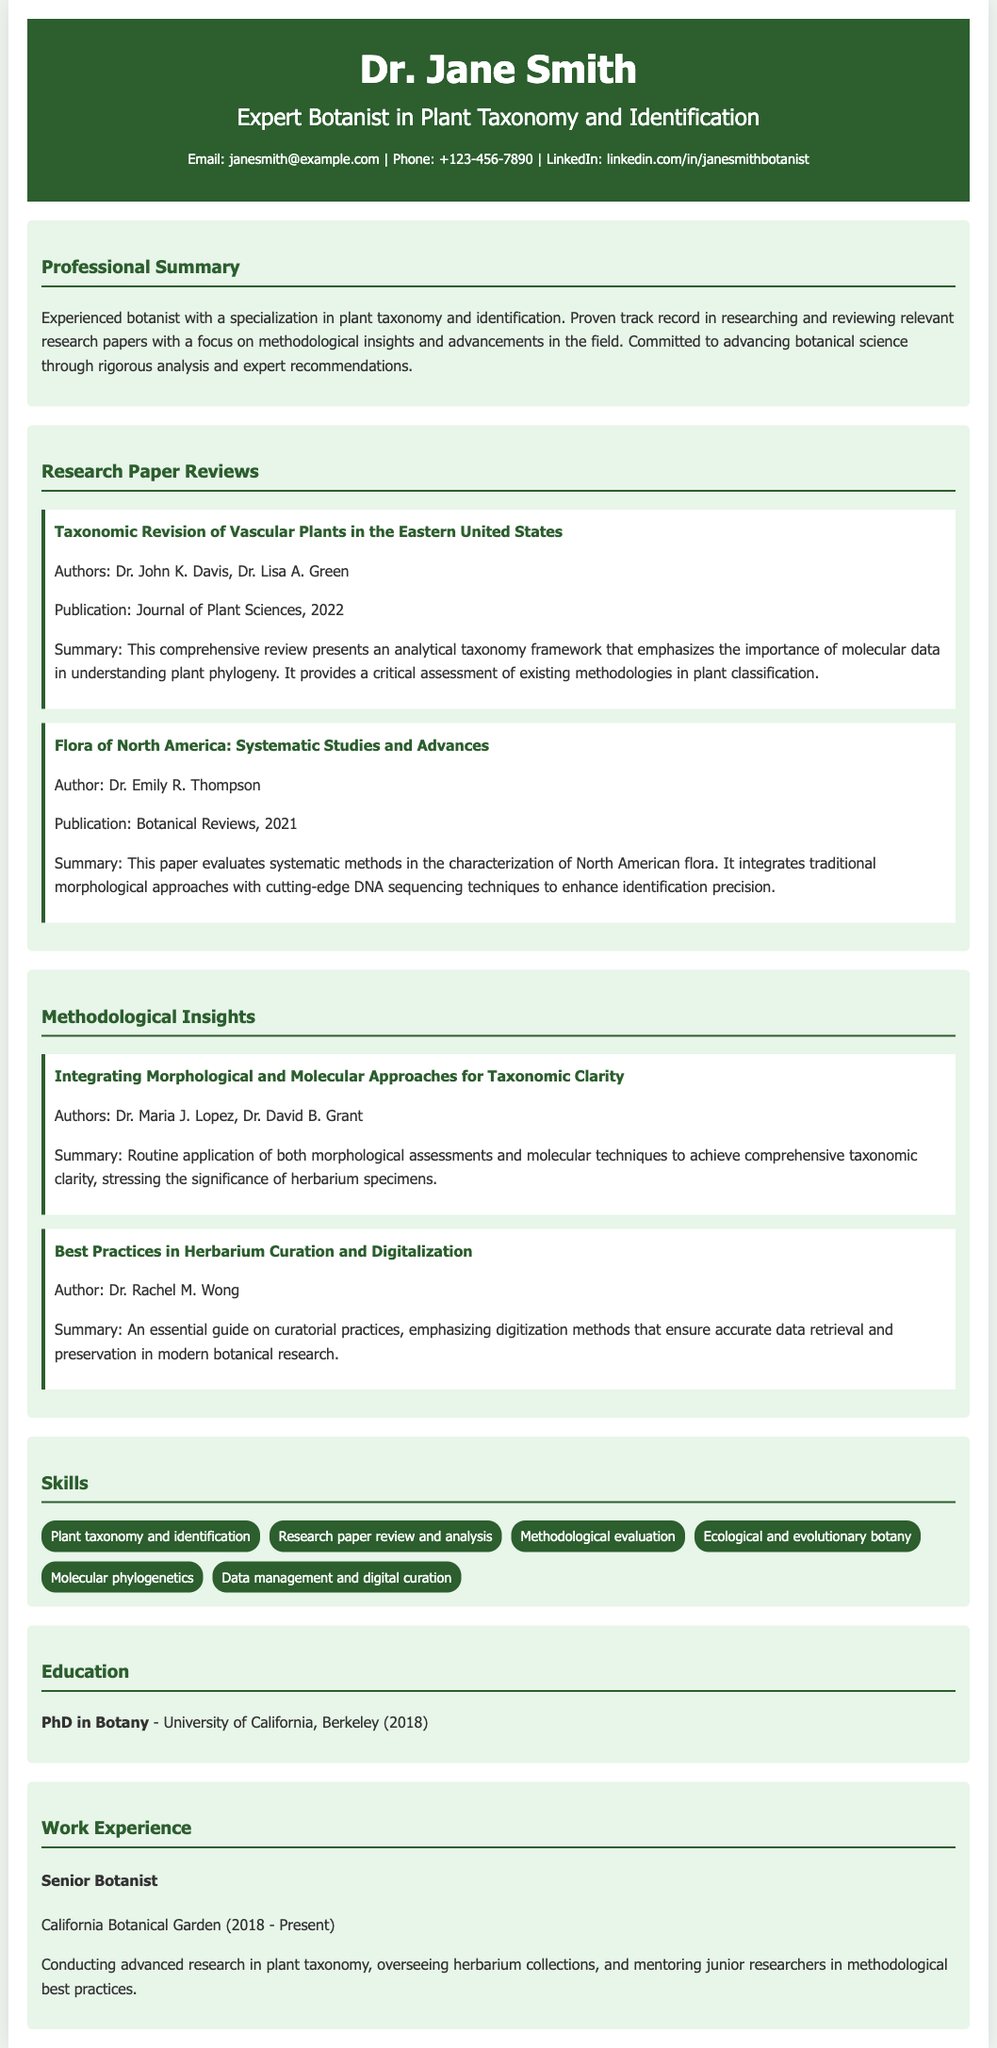what is the name of the expert botanist? The name of the expert botanist is listed at the top of the document, which is Dr. Jane Smith.
Answer: Dr. Jane Smith what is Dr. Jane Smith's area of expertise? The document specifies that her expertise is in plant taxonomy and identification.
Answer: plant taxonomy and identification which research paper discusses molecular data in taxonomy? The paper's title that discusses the importance of molecular data in understanding plant phylogeny is provided in the reviews section.
Answer: Taxonomic Revision of Vascular Plants in the Eastern United States who authored the paper on best practices in herbarium curation? The author's name for the paper on herbarium curation is mentioned in the insights section of the document.
Answer: Dr. Rachel M. Wong what year did Dr. Jane Smith receive her PhD? The document details her educational background, specifically the year she completed her doctoral degree.
Answer: 2018 how many research paper reviews are listed in the document? The number of research paper reviews can be counted in the section provided, which is a specific aspect of the document.
Answer: 2 what is the title of Dr. Jane Smith's current position? The title of her current job is mentioned in the work experience section of the resume.
Answer: Senior Botanist how many skills are listed in the skills section? The number of skills can be gleaned by counting the entries in that section of the document.
Answer: 6 what aspect does the methodological insight paper emphasize? The methodological insight paper's summary indicates a focus on a specific approach in taxonomic clarity.
Answer: integrating morphological and molecular approaches 